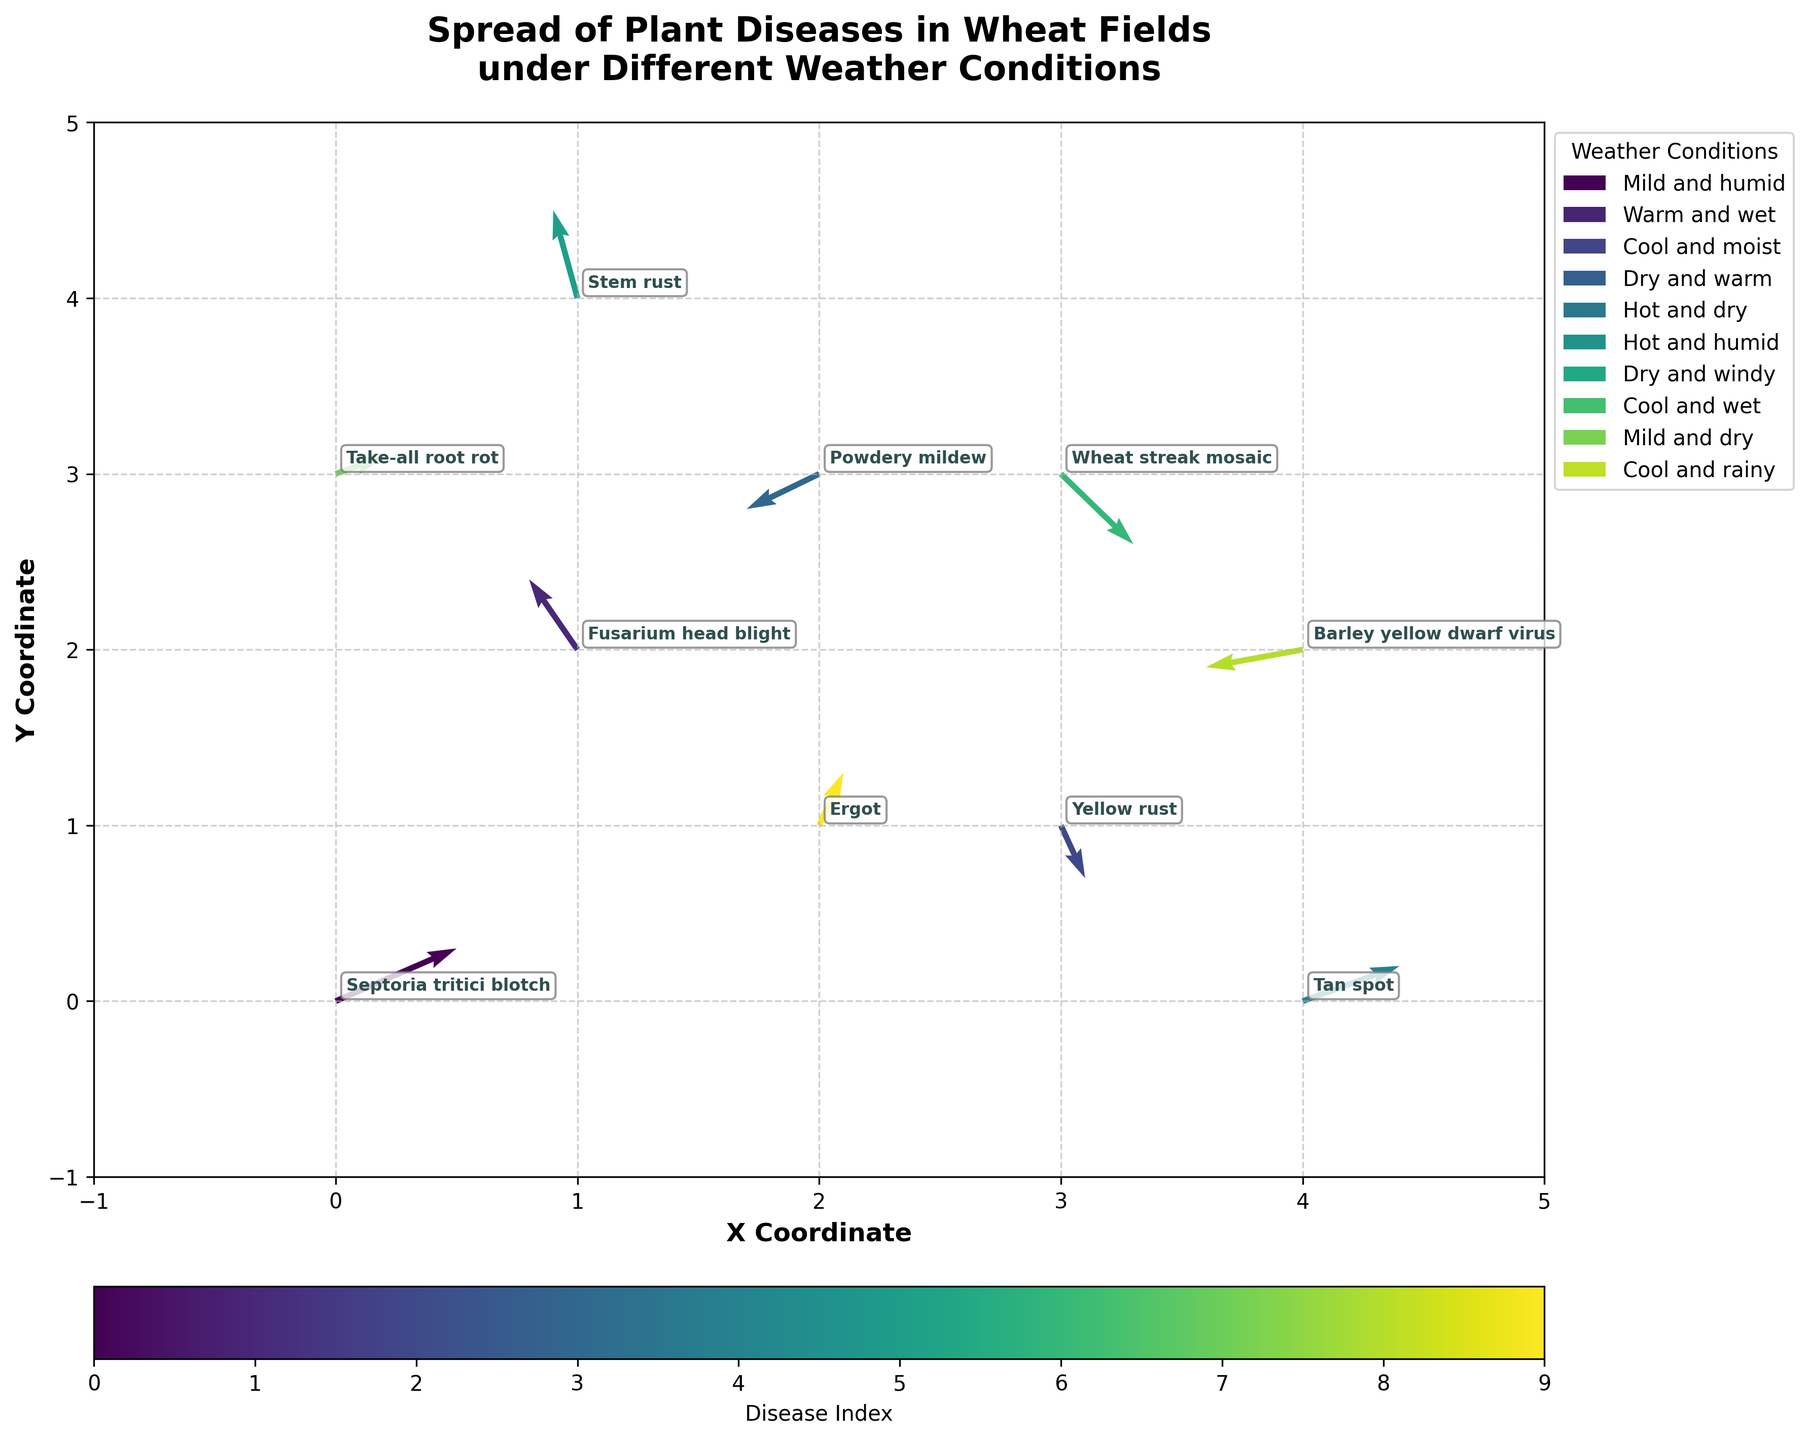What is the title of the figure? The title of a figure is typically located at the top of the plot and provides a concise summary of what the figure represents. In this case, it explains that the plot displays the spread of plant diseases in wheat fields under different weather conditions.
Answer: Spread of Plant Diseases in Wheat Fields under Different Weather Conditions What is the X coordinate of the disease "Fusarium head blight"? The X coordinate is labelled along the horizontal axis (usually at the bottom). The disease labels are annotated at specific points, and for "Fusarium head blight," the corresponding X coordinate is where its label is placed.
Answer: 1 Which disease has the greatest magnitude of spread in the positive Y direction? The magnitude of spread in the positive Y direction is indicated by the length and direction of the arrows (v component). By visually inspecting the plot, we identify that "Stem rust" has the arrow with the greatest upward length.
Answer: Stem rust Compare the spread direction of "Yellow rust" and "Powdery mildew". Which one has a more significant spread in the negative Y direction? We need to compare the Y components (v values) of the arrows for these two diseases. "Yellow rust" has a v value of -0.3, while "Powdery mildew" has a v value of -0.2. Therefore, "Yellow rust" has a more significant spread in the negative Y direction.
Answer: Yellow rust What is the general weather condition associated with "Take-all root rot"? The weather conditions are mapped to the diseases using a legend. By finding "Take-all root rot" in the plot and referring to the legend, we can identify its corresponding weather condition.
Answer: Cool and wet Which disease shows spread only in the positive X direction without any Y movement? Analyzing the plot, we look for an arrow that points horizontally to the right only, indicating a positive X direction (u value) with no Y movement (v value). "Tan spot" fits this description with a u value of 0.4 and v value of 0.2.
Answer: There’s an error: "Tan spot" also has a Y component. None strictly fits the description Identify the disease with the most complex spread pattern (longest arrow) by combining the X and Y components. To determine the most complex or longest spread pattern, we calculate the magnitude of the vectors (√(u^2 + v^2)) for each disease. "Stem rust" has a substantial spread with u=-0.1 and v=0.5, giving a vector magnitude of √((-0.1)^2 + 0.5^2) = 0.51.
Answer: Stem rust Which weather condition is associated with the disease having the largest negative X component? We need to identify the disease with the largest negative X component (u value) and check its corresponding weather condition in the plot and legend. "Barley yellow dwarf virus" has the largest negative X component (-0.4), with a weather condition of "Mild and dry".
Answer: Mild and dry 